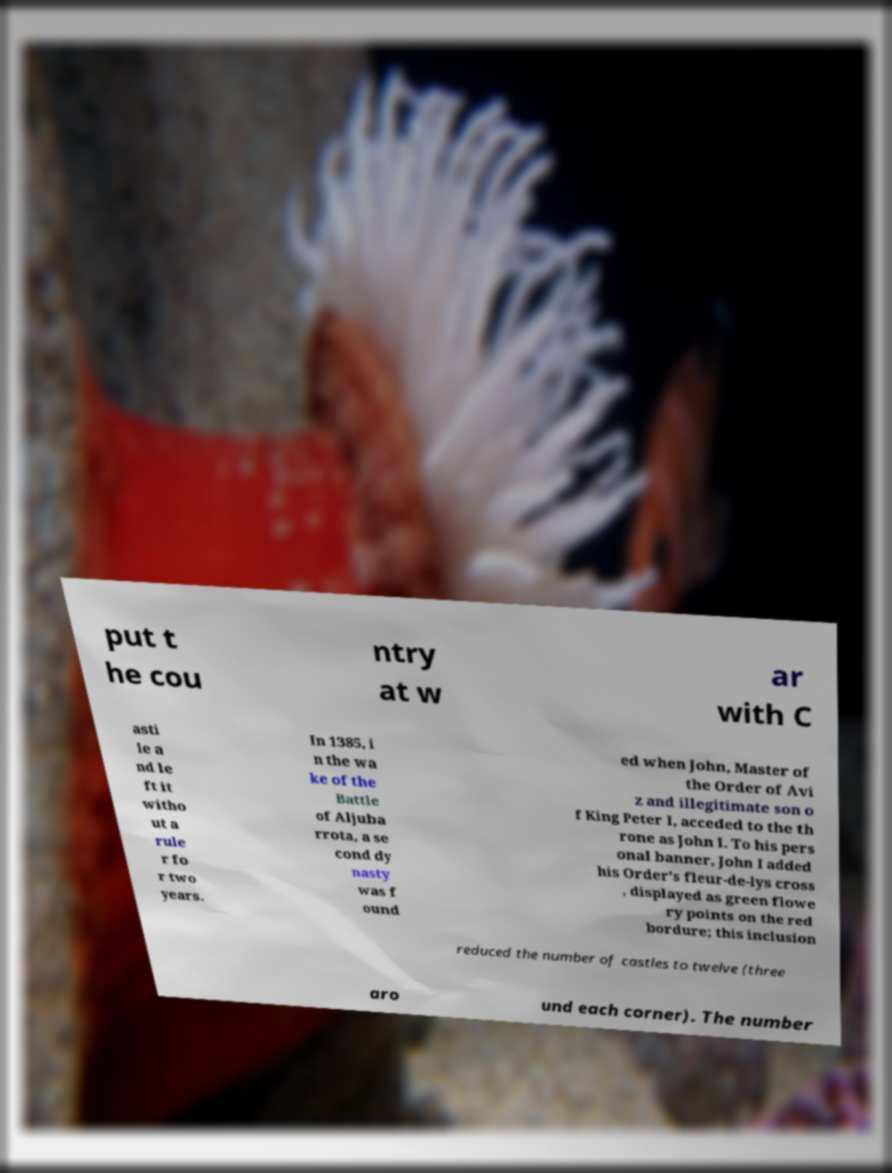What messages or text are displayed in this image? I need them in a readable, typed format. put t he cou ntry at w ar with C asti le a nd le ft it witho ut a rule r fo r two years. In 1385, i n the wa ke of the Battle of Aljuba rrota, a se cond dy nasty was f ound ed when John, Master of the Order of Avi z and illegitimate son o f King Peter I, acceded to the th rone as John I. To his pers onal banner, John I added his Order's fleur-de-lys cross , displayed as green flowe ry points on the red bordure; this inclusion reduced the number of castles to twelve (three aro und each corner). The number 